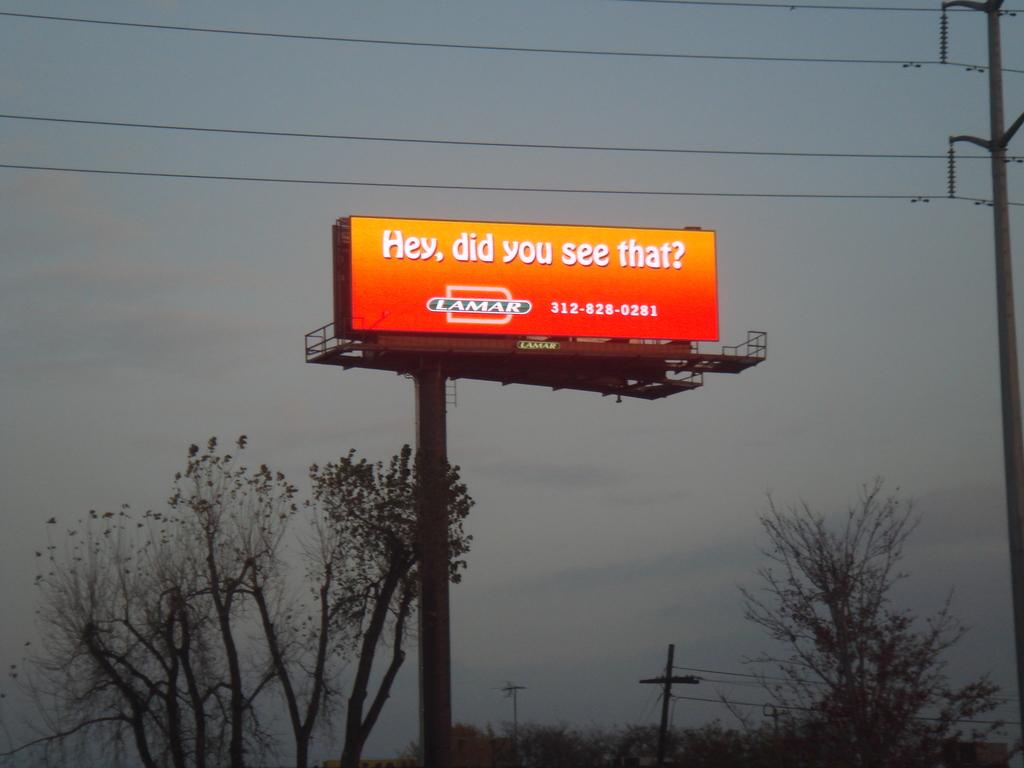Provide a one-sentence caption for the provided image. A company called Lamar poses a cryptic question with an orange billboard. 